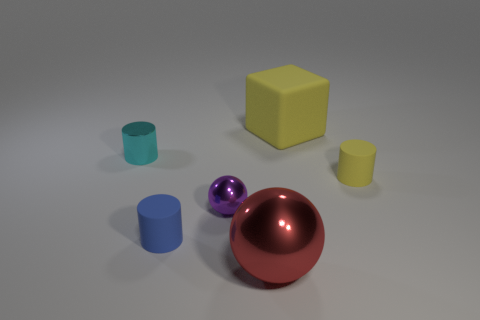Are there any purple objects that have the same shape as the large red shiny object?
Offer a terse response. Yes. There is a yellow object that is the same size as the purple thing; what shape is it?
Give a very brief answer. Cylinder. Does the small sphere have the same color as the small matte object that is to the left of the big red ball?
Your response must be concise. No. There is a yellow rubber object in front of the cyan object; what number of tiny cylinders are to the left of it?
Offer a terse response. 2. There is a rubber thing that is right of the tiny purple metallic object and in front of the rubber cube; what size is it?
Provide a succinct answer. Small. Is there a brown ball that has the same size as the yellow cylinder?
Provide a succinct answer. No. Is the number of small shiny balls to the right of the big sphere greater than the number of red objects that are behind the small cyan cylinder?
Make the answer very short. No. Do the purple ball and the yellow thing that is in front of the small metal cylinder have the same material?
Offer a very short reply. No. How many small objects are on the left side of the cylinder that is in front of the small thing that is right of the small metal ball?
Provide a short and direct response. 1. There is a large yellow thing; does it have the same shape as the tiny object that is right of the large metallic thing?
Provide a succinct answer. No. 